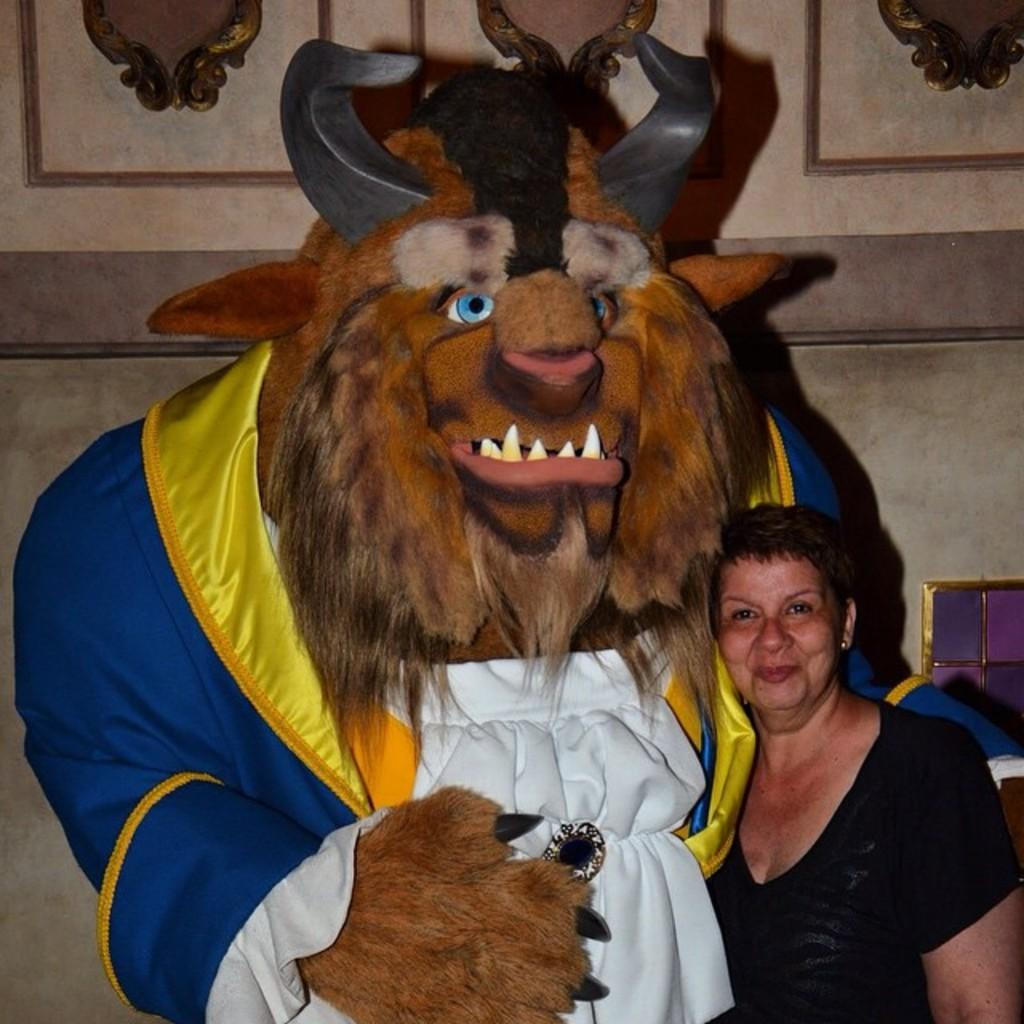Who is present in the image? There is a woman in the image. What is the woman wearing? The woman is wearing a black t-shirt. What is the woman's facial expression? The woman is smiling. What can be seen near the woman in the image? The woman is standing near a statue. What is visible in the background of the image? There is a wall in the background of the image. What type of rice is being served on the island in the image? There is no rice or island present in the image; it features a woman standing near a statue with a wall in the background. 